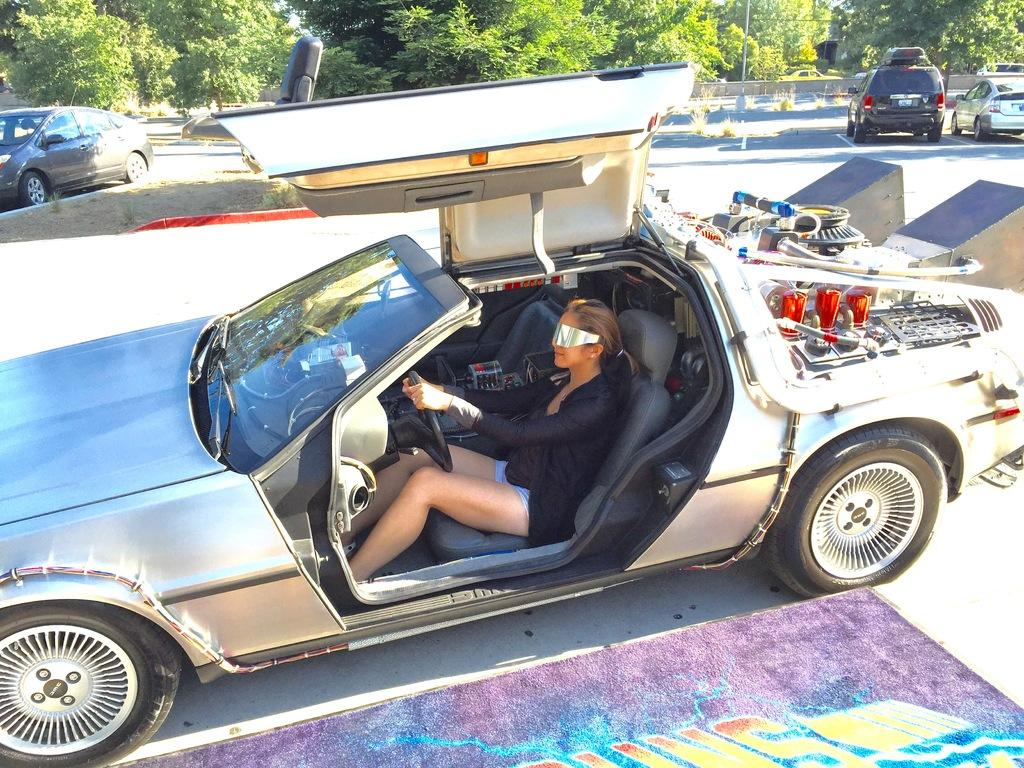What can be seen on the road in the image? There are vehicles on the road in the image. What else is visible in the image besides the vehicles? There are trees visible in the image. Can you describe the woman in the image? The woman is sitting in a vehicle and holding a steering wheel with her hands. What type of adjustment can be seen on the coil in the image? There is no coil present in the image. How does the woman perform the trick with the steering wheel in the image? The woman is not performing any tricks with the steering wheel in the image; she is simply holding it with her hands. 